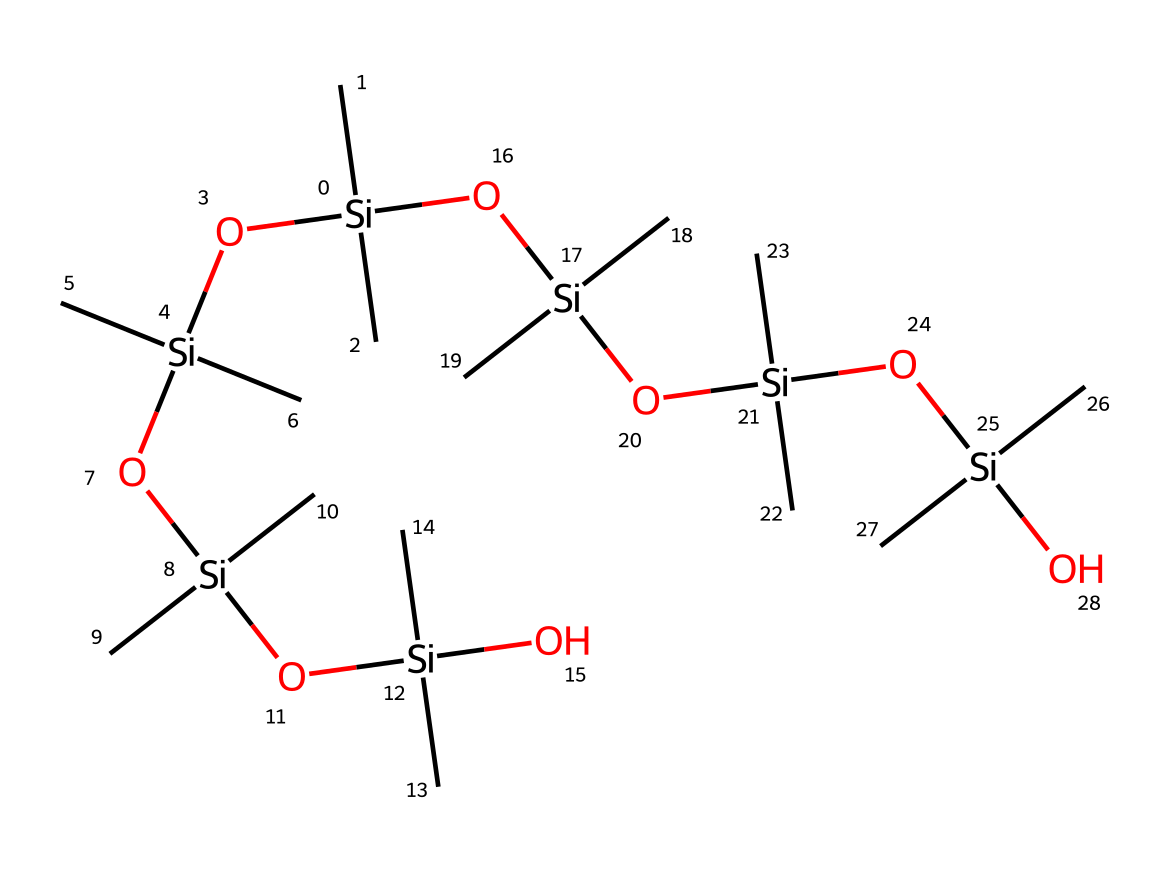What is the main element in this silicone polymer? The structure prominently features silicon atoms (Si), which are the central building blocks of the polymer's backbone. This is observable from the repeated Si in the SMILES notation.
Answer: silicon How many silicon atoms are present in the structure? By analyzing the SMILES representation, we can count each 'Si' occurrence, which totals to ten silicon atoms (including those in the brackets).
Answer: ten What type of chemical is represented here? The structure is characteristic of a silicone polymer, which is confirmed by the silicon-oxygen (Si-O) connectivity and its non-electrolyte nature.
Answer: silicone polymer What types of functional groups can be identified in this silicon polymer? The prominent functional groups in this structure are silanol groups (–Si(OH)–) and siloxy groups (–Si–O–Si–), seen through the connectivity of Si to both carbon and oxygen atoms.
Answer: silanol and siloxy Which property allows silicone polymers to be suitable for customized phone cases? The viscoelastic nature of silicone polymers, arising from their silicone backbone and flexible –C– linkage, provides excellent shock absorption and durability, making them ideal for phone cases.
Answer: viscoelastic How do the silicone polymer's properties affect its use as a non-electrolyte? Silicone polymers do not dissociate into ions in solution, maintaining their non-electrolytic properties, which aids in creating effective barrier materials in products such as phone cases.
Answer: does not dissociate 